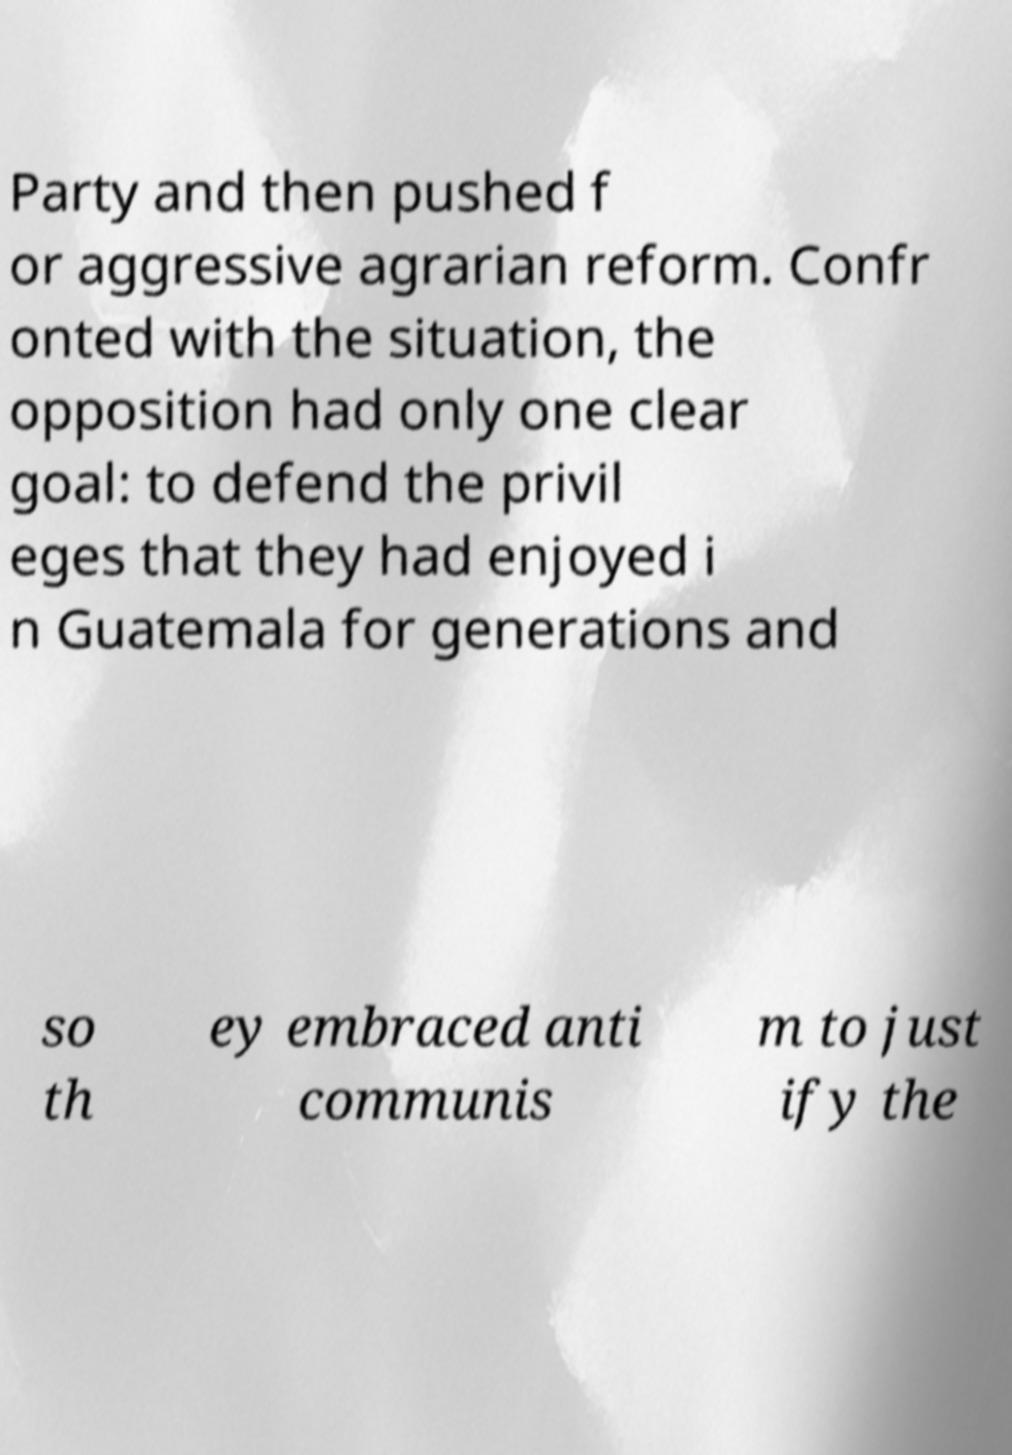Please identify and transcribe the text found in this image. Party and then pushed f or aggressive agrarian reform. Confr onted with the situation, the opposition had only one clear goal: to defend the privil eges that they had enjoyed i n Guatemala for generations and so th ey embraced anti communis m to just ify the 